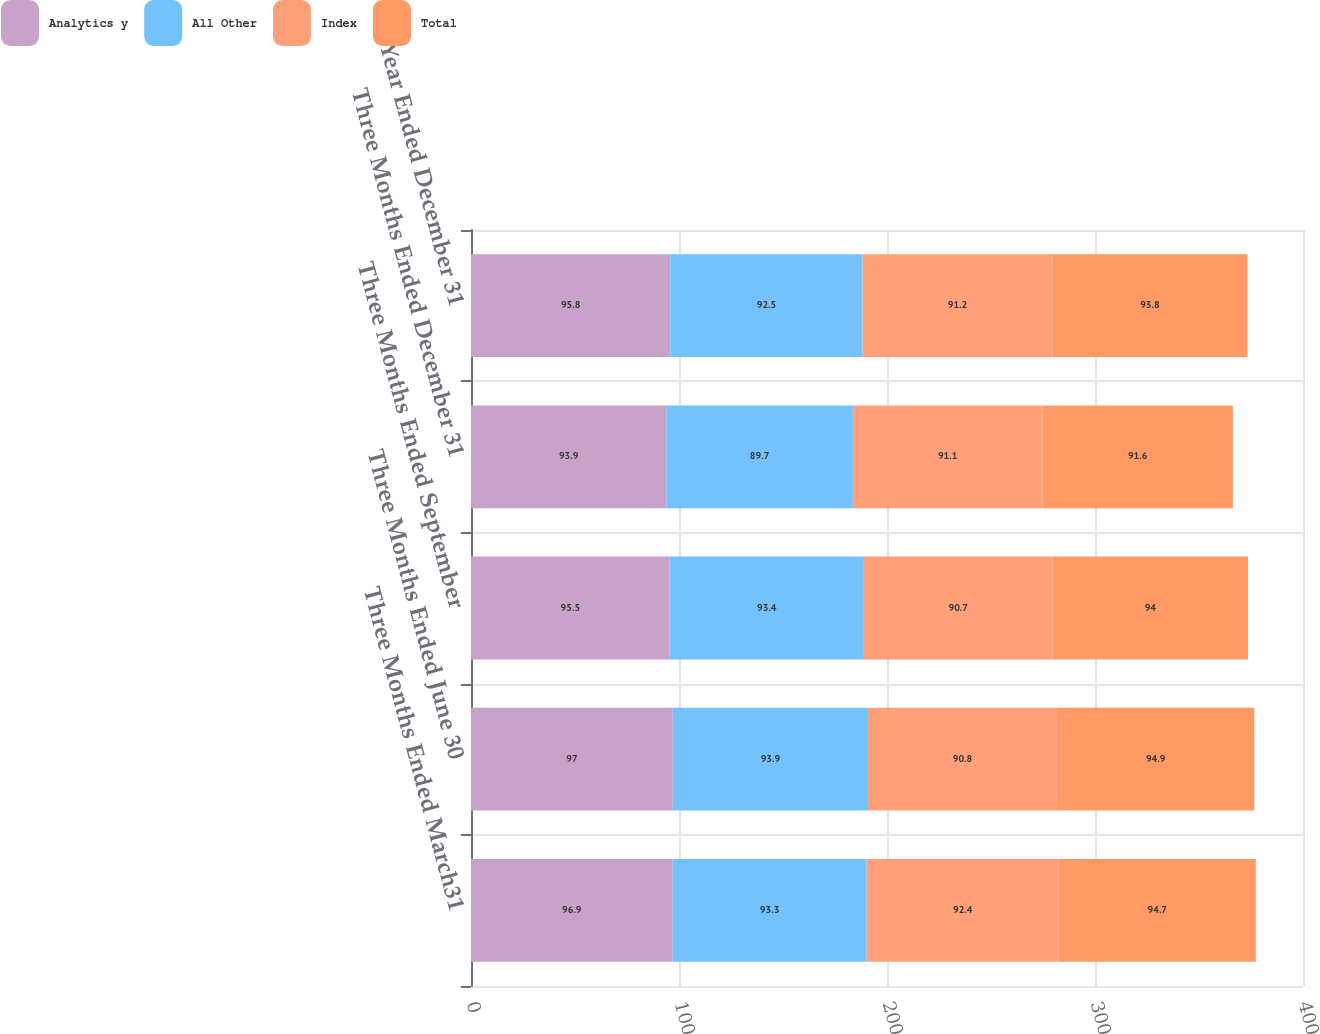Convert chart. <chart><loc_0><loc_0><loc_500><loc_500><stacked_bar_chart><ecel><fcel>Three Months Ended March31<fcel>Three Months Ended June 30<fcel>Three Months Ended September<fcel>Three Months Ended December 31<fcel>Year Ended December 31<nl><fcel>Analytics y<fcel>96.9<fcel>97<fcel>95.5<fcel>93.9<fcel>95.8<nl><fcel>All Other<fcel>93.3<fcel>93.9<fcel>93.4<fcel>89.7<fcel>92.5<nl><fcel>Index<fcel>92.4<fcel>90.8<fcel>90.7<fcel>91.1<fcel>91.2<nl><fcel>Total<fcel>94.7<fcel>94.9<fcel>94<fcel>91.6<fcel>93.8<nl></chart> 